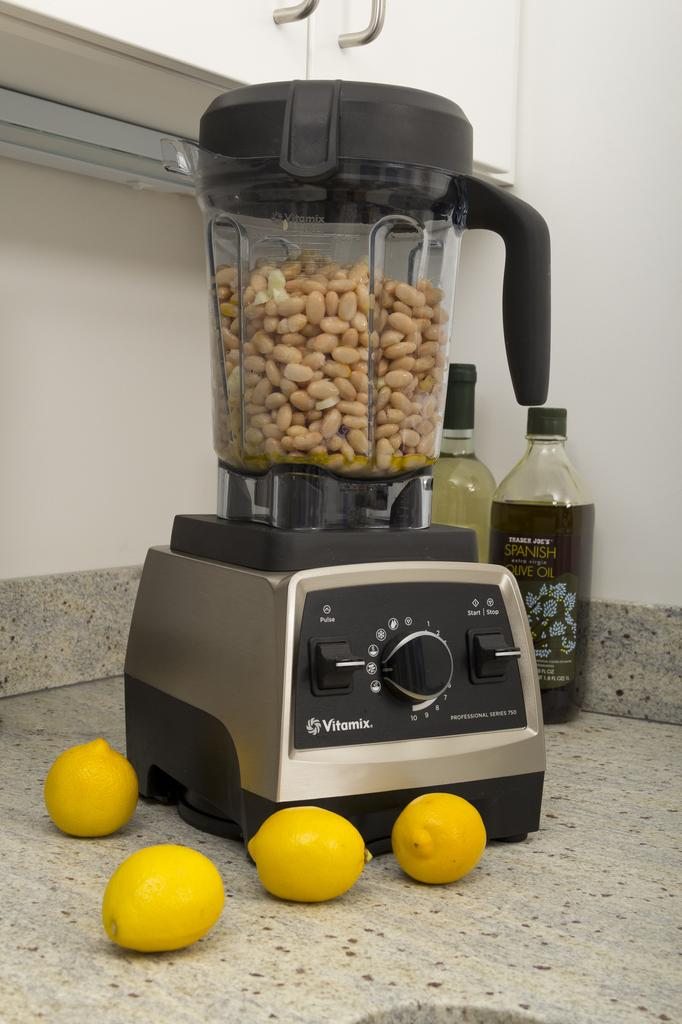<image>
Render a clear and concise summary of the photo. A professional series 750 blender full of nuts sitting on a marble counter surrounded by lemons. 